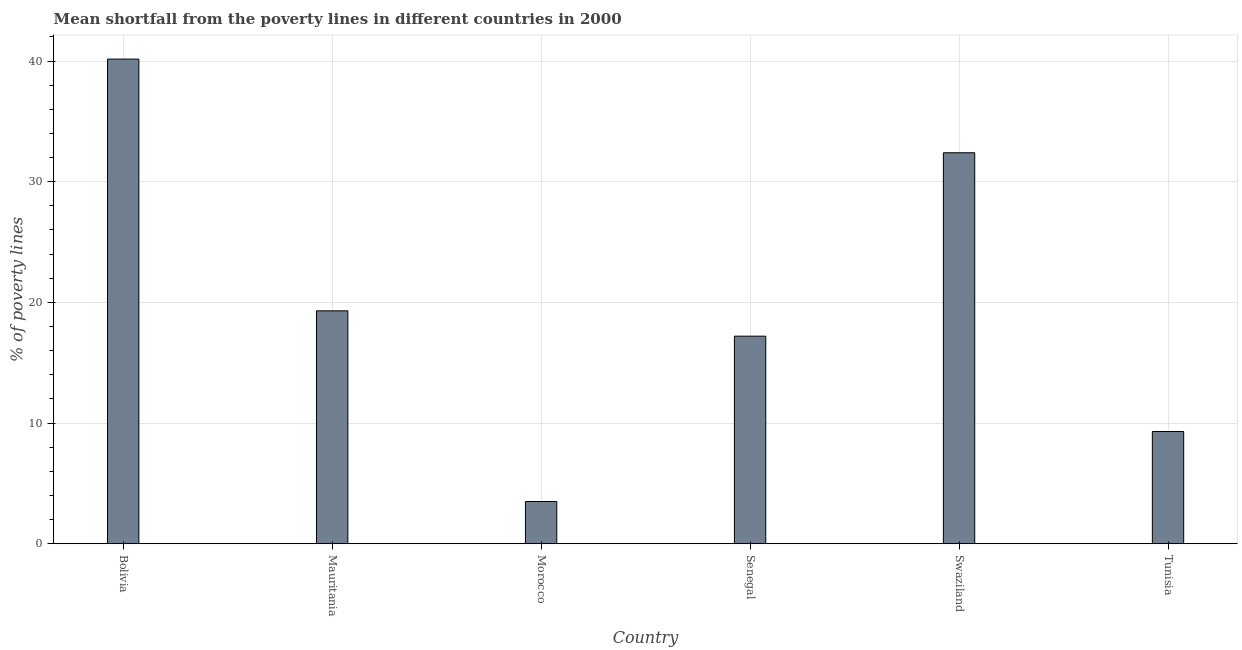Does the graph contain any zero values?
Keep it short and to the point. No. Does the graph contain grids?
Ensure brevity in your answer.  Yes. What is the title of the graph?
Give a very brief answer. Mean shortfall from the poverty lines in different countries in 2000. What is the label or title of the X-axis?
Offer a terse response. Country. What is the label or title of the Y-axis?
Keep it short and to the point. % of poverty lines. What is the poverty gap at national poverty lines in Mauritania?
Your response must be concise. 19.3. Across all countries, what is the maximum poverty gap at national poverty lines?
Ensure brevity in your answer.  40.16. In which country was the poverty gap at national poverty lines maximum?
Your answer should be compact. Bolivia. In which country was the poverty gap at national poverty lines minimum?
Provide a succinct answer. Morocco. What is the sum of the poverty gap at national poverty lines?
Ensure brevity in your answer.  121.86. What is the difference between the poverty gap at national poverty lines in Mauritania and Senegal?
Your answer should be very brief. 2.1. What is the average poverty gap at national poverty lines per country?
Keep it short and to the point. 20.31. What is the median poverty gap at national poverty lines?
Provide a short and direct response. 18.25. In how many countries, is the poverty gap at national poverty lines greater than 24 %?
Make the answer very short. 2. What is the ratio of the poverty gap at national poverty lines in Bolivia to that in Tunisia?
Your answer should be compact. 4.32. Is the poverty gap at national poverty lines in Mauritania less than that in Tunisia?
Offer a very short reply. No. Is the difference between the poverty gap at national poverty lines in Mauritania and Morocco greater than the difference between any two countries?
Your answer should be compact. No. What is the difference between the highest and the second highest poverty gap at national poverty lines?
Provide a succinct answer. 7.76. Is the sum of the poverty gap at national poverty lines in Bolivia and Tunisia greater than the maximum poverty gap at national poverty lines across all countries?
Ensure brevity in your answer.  Yes. What is the difference between the highest and the lowest poverty gap at national poverty lines?
Provide a succinct answer. 36.66. In how many countries, is the poverty gap at national poverty lines greater than the average poverty gap at national poverty lines taken over all countries?
Your answer should be compact. 2. How many bars are there?
Provide a succinct answer. 6. Are all the bars in the graph horizontal?
Your answer should be compact. No. How many countries are there in the graph?
Offer a very short reply. 6. Are the values on the major ticks of Y-axis written in scientific E-notation?
Provide a short and direct response. No. What is the % of poverty lines of Bolivia?
Your response must be concise. 40.16. What is the % of poverty lines in Mauritania?
Give a very brief answer. 19.3. What is the % of poverty lines of Morocco?
Provide a short and direct response. 3.5. What is the % of poverty lines in Swaziland?
Keep it short and to the point. 32.4. What is the difference between the % of poverty lines in Bolivia and Mauritania?
Give a very brief answer. 20.86. What is the difference between the % of poverty lines in Bolivia and Morocco?
Offer a terse response. 36.66. What is the difference between the % of poverty lines in Bolivia and Senegal?
Offer a very short reply. 22.96. What is the difference between the % of poverty lines in Bolivia and Swaziland?
Make the answer very short. 7.76. What is the difference between the % of poverty lines in Bolivia and Tunisia?
Your answer should be compact. 30.86. What is the difference between the % of poverty lines in Mauritania and Morocco?
Your answer should be compact. 15.8. What is the difference between the % of poverty lines in Mauritania and Senegal?
Your answer should be compact. 2.1. What is the difference between the % of poverty lines in Morocco and Senegal?
Keep it short and to the point. -13.7. What is the difference between the % of poverty lines in Morocco and Swaziland?
Keep it short and to the point. -28.9. What is the difference between the % of poverty lines in Senegal and Swaziland?
Provide a short and direct response. -15.2. What is the difference between the % of poverty lines in Swaziland and Tunisia?
Ensure brevity in your answer.  23.1. What is the ratio of the % of poverty lines in Bolivia to that in Mauritania?
Offer a very short reply. 2.08. What is the ratio of the % of poverty lines in Bolivia to that in Morocco?
Give a very brief answer. 11.47. What is the ratio of the % of poverty lines in Bolivia to that in Senegal?
Keep it short and to the point. 2.33. What is the ratio of the % of poverty lines in Bolivia to that in Swaziland?
Your answer should be very brief. 1.24. What is the ratio of the % of poverty lines in Bolivia to that in Tunisia?
Provide a short and direct response. 4.32. What is the ratio of the % of poverty lines in Mauritania to that in Morocco?
Your response must be concise. 5.51. What is the ratio of the % of poverty lines in Mauritania to that in Senegal?
Your response must be concise. 1.12. What is the ratio of the % of poverty lines in Mauritania to that in Swaziland?
Offer a very short reply. 0.6. What is the ratio of the % of poverty lines in Mauritania to that in Tunisia?
Your answer should be compact. 2.08. What is the ratio of the % of poverty lines in Morocco to that in Senegal?
Your answer should be compact. 0.2. What is the ratio of the % of poverty lines in Morocco to that in Swaziland?
Your response must be concise. 0.11. What is the ratio of the % of poverty lines in Morocco to that in Tunisia?
Give a very brief answer. 0.38. What is the ratio of the % of poverty lines in Senegal to that in Swaziland?
Keep it short and to the point. 0.53. What is the ratio of the % of poverty lines in Senegal to that in Tunisia?
Provide a succinct answer. 1.85. What is the ratio of the % of poverty lines in Swaziland to that in Tunisia?
Offer a terse response. 3.48. 